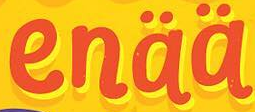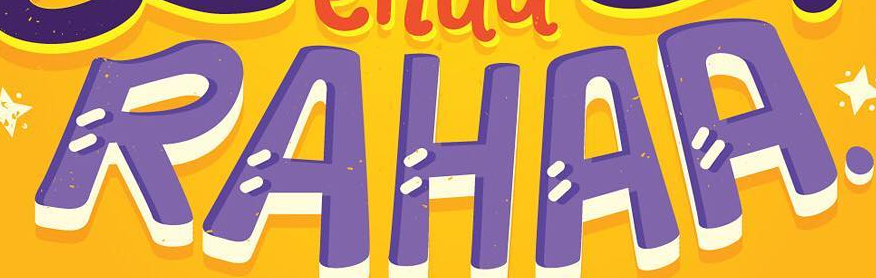Read the text from these images in sequence, separated by a semicolon. enää; RAHAA 